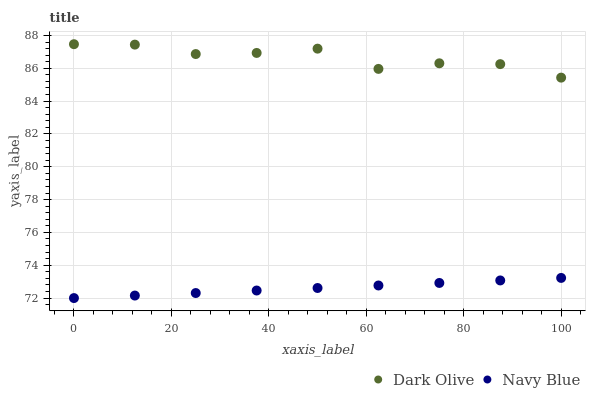Does Navy Blue have the minimum area under the curve?
Answer yes or no. Yes. Does Dark Olive have the maximum area under the curve?
Answer yes or no. Yes. Does Dark Olive have the minimum area under the curve?
Answer yes or no. No. Is Navy Blue the smoothest?
Answer yes or no. Yes. Is Dark Olive the roughest?
Answer yes or no. Yes. Is Dark Olive the smoothest?
Answer yes or no. No. Does Navy Blue have the lowest value?
Answer yes or no. Yes. Does Dark Olive have the lowest value?
Answer yes or no. No. Does Dark Olive have the highest value?
Answer yes or no. Yes. Is Navy Blue less than Dark Olive?
Answer yes or no. Yes. Is Dark Olive greater than Navy Blue?
Answer yes or no. Yes. Does Navy Blue intersect Dark Olive?
Answer yes or no. No. 